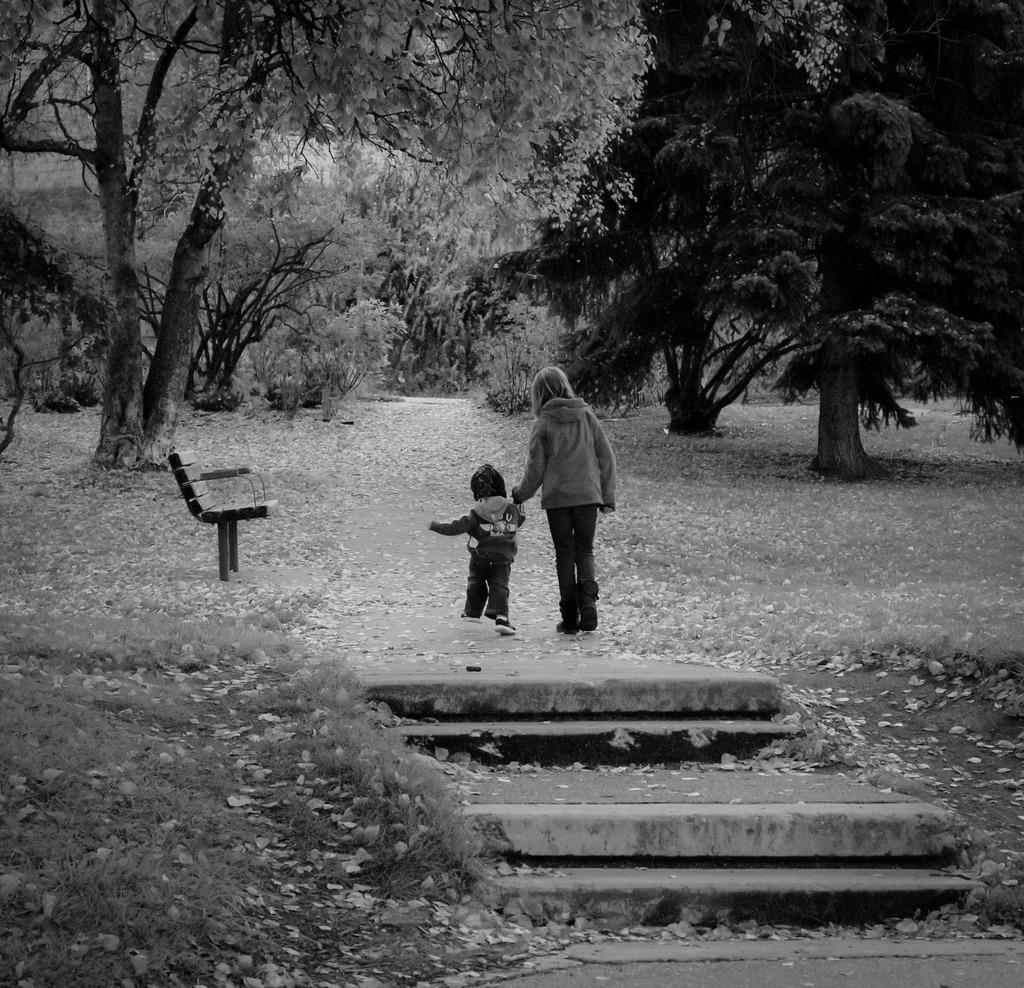Could you give a brief overview of what you see in this image? Here we can see a Woman and Child walking through a park and beside them we can see a bench and a lot of trees 